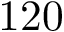<formula> <loc_0><loc_0><loc_500><loc_500>1 2 0</formula> 